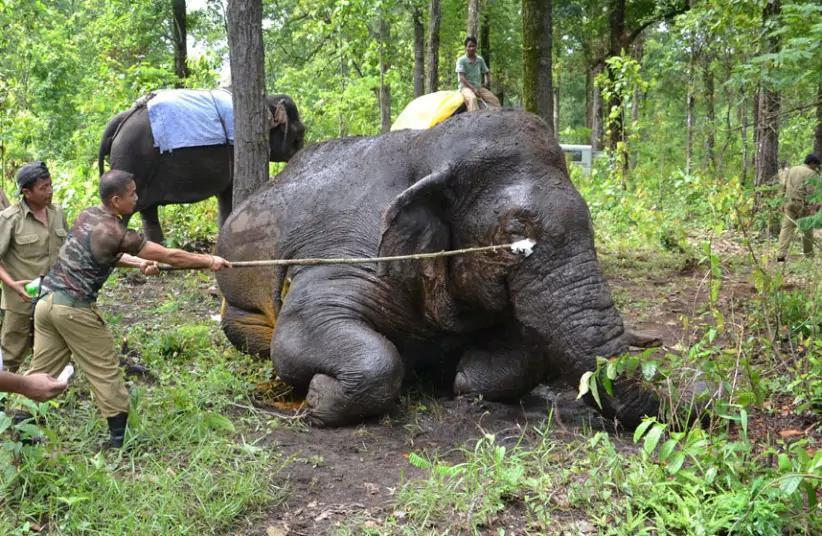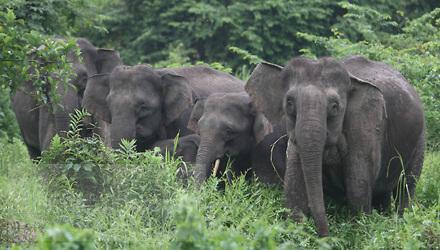The first image is the image on the left, the second image is the image on the right. Analyze the images presented: Is the assertion "Only one image shows a single elephant with tusks." valid? Answer yes or no. No. The first image is the image on the left, the second image is the image on the right. Given the left and right images, does the statement "There is exactly one elephant in the image on the right." hold true? Answer yes or no. No. 